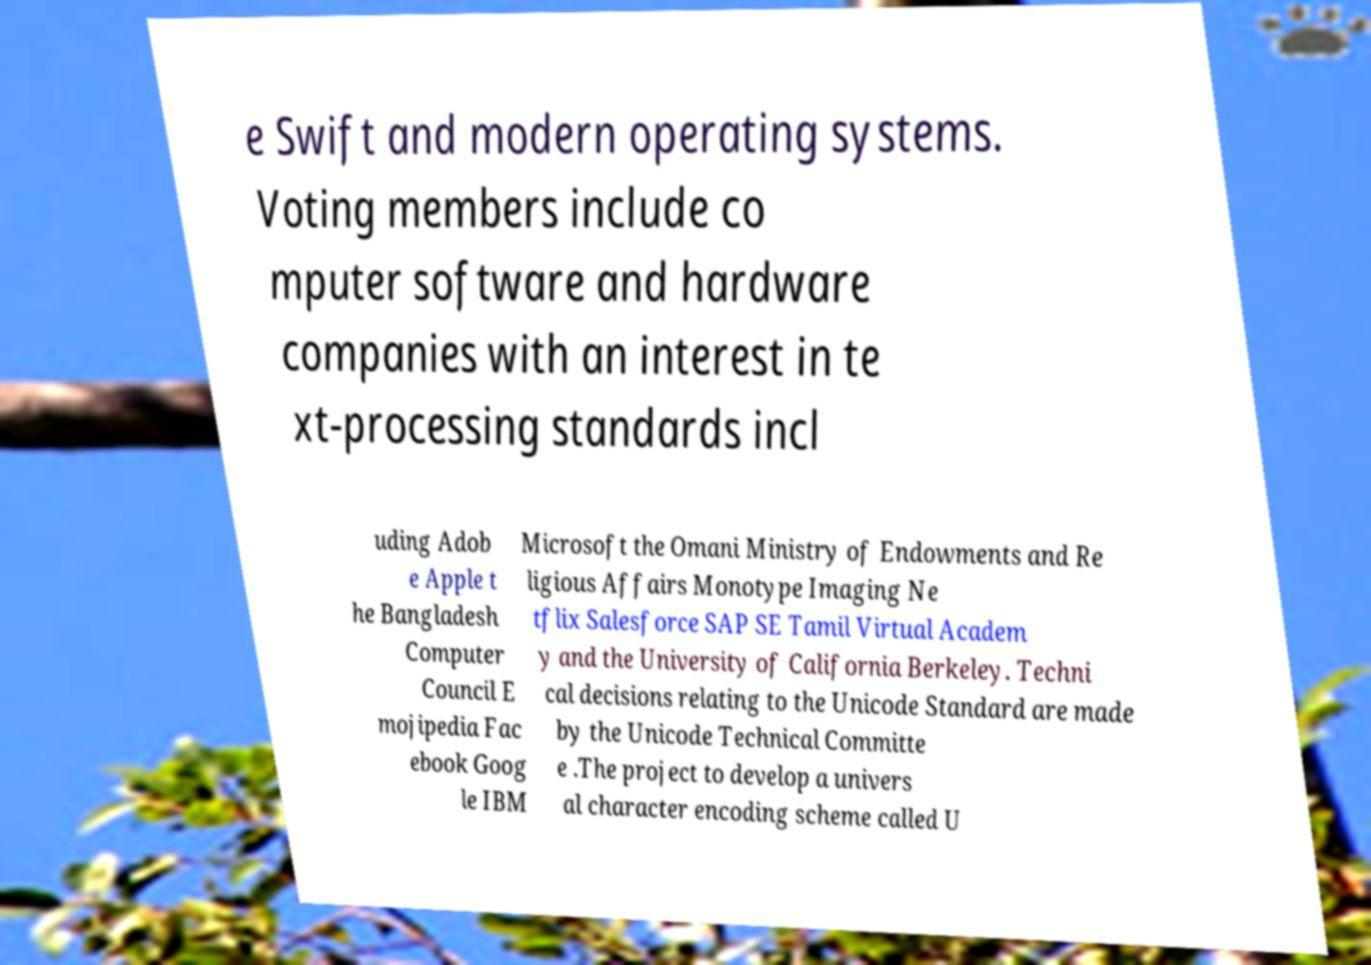Please identify and transcribe the text found in this image. e Swift and modern operating systems. Voting members include co mputer software and hardware companies with an interest in te xt-processing standards incl uding Adob e Apple t he Bangladesh Computer Council E mojipedia Fac ebook Goog le IBM Microsoft the Omani Ministry of Endowments and Re ligious Affairs Monotype Imaging Ne tflix Salesforce SAP SE Tamil Virtual Academ y and the University of California Berkeley. Techni cal decisions relating to the Unicode Standard are made by the Unicode Technical Committe e .The project to develop a univers al character encoding scheme called U 